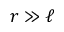Convert formula to latex. <formula><loc_0><loc_0><loc_500><loc_500>r \gg \ell</formula> 